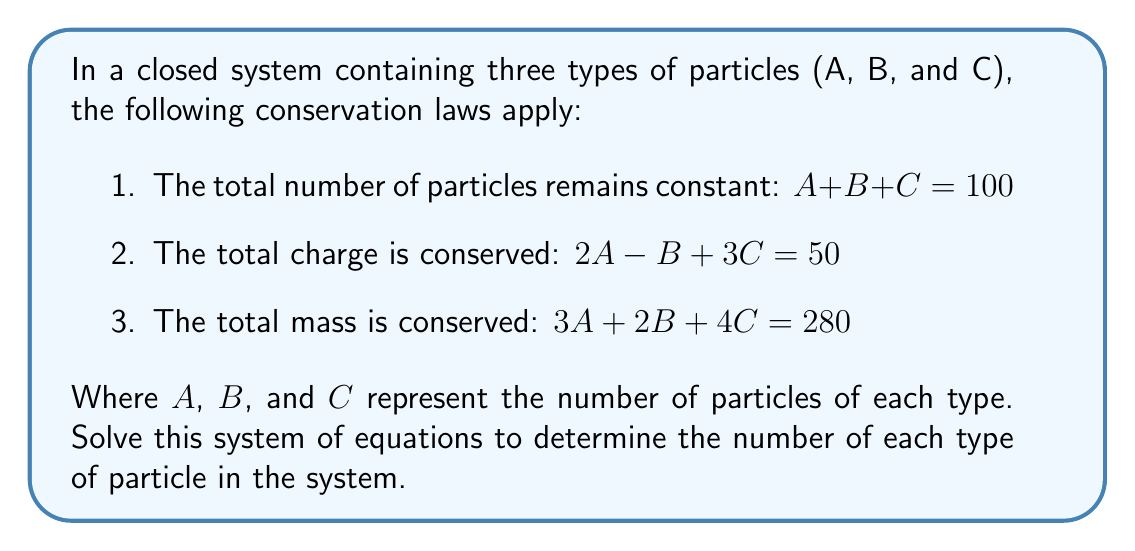Give your solution to this math problem. Let's solve this system of equations using the elimination method:

1) First, let's eliminate $C$ from equations 1 and 2:
   Multiply equation 1 by 3: $3A + 3B + 3C = 300$
   Subtract equation 2:      $2A - B + 3C = 50$
   Result:                   $A + 4B = 250$ (Equation 4)

2) Now, let's eliminate $C$ from equations 1 and 3:
   Multiply equation 1 by 4: $4A + 4B + 4C = 400$
   Subtract equation 3:      $3A + 2B + 4C = 280$
   Result:                   $A + 2B = 120$ (Equation 5)

3) We now have a system of two equations with two unknowns:
   $A + 4B = 250$ (Equation 4)
   $A + 2B = 120$ (Equation 5)

4) Subtract equation 5 from equation 4:
   $2B = 130$
   $B = 65$

5) Substitute $B = 65$ into equation 5:
   $A + 2(65) = 120$
   $A = 120 - 130 = -10$

6) Now we can find $C$ using equation 1:
   $A + B + C = 100$
   $-10 + 65 + C = 100$
   $C = 45$

7) Let's verify our solution satisfies all three original equations:
   Equation 1: $-10 + 65 + 45 = 100$ ✓
   Equation 2: $2(-10) - 65 + 3(45) = -20 - 65 + 135 = 50$ ✓
   Equation 3: $3(-10) + 2(65) + 4(45) = -30 + 130 + 180 = 280$ ✓

Therefore, the solution is $A = -10$, $B = 65$, and $C = 45$.
Answer: $A = -10$, $B = 65$, $C = 45$ 